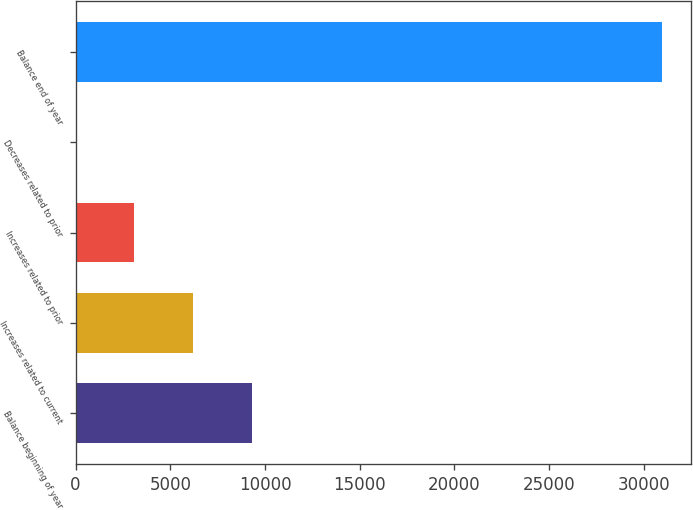Convert chart to OTSL. <chart><loc_0><loc_0><loc_500><loc_500><bar_chart><fcel>Balance beginning of year<fcel>Increases related to current<fcel>Increases related to prior<fcel>Decreases related to prior<fcel>Balance end of year<nl><fcel>9292.4<fcel>6198.6<fcel>3104.8<fcel>11<fcel>30949<nl></chart> 